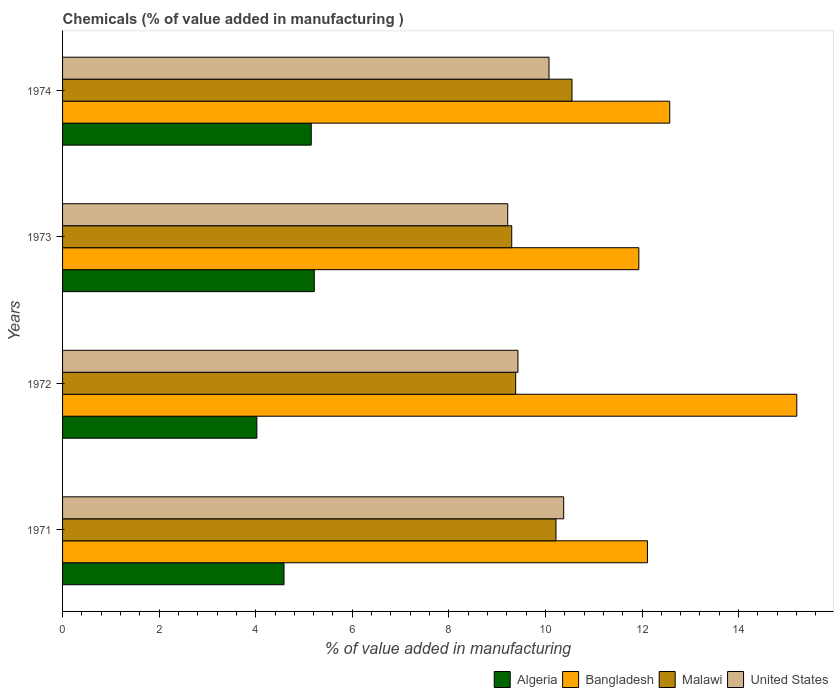Are the number of bars on each tick of the Y-axis equal?
Offer a very short reply. Yes. How many bars are there on the 1st tick from the top?
Keep it short and to the point. 4. What is the value added in manufacturing chemicals in Malawi in 1971?
Your answer should be compact. 10.22. Across all years, what is the maximum value added in manufacturing chemicals in Malawi?
Offer a terse response. 10.55. Across all years, what is the minimum value added in manufacturing chemicals in United States?
Your response must be concise. 9.22. In which year was the value added in manufacturing chemicals in United States maximum?
Ensure brevity in your answer.  1971. In which year was the value added in manufacturing chemicals in Malawi minimum?
Keep it short and to the point. 1973. What is the total value added in manufacturing chemicals in Malawi in the graph?
Provide a succinct answer. 39.45. What is the difference between the value added in manufacturing chemicals in United States in 1972 and that in 1974?
Keep it short and to the point. -0.64. What is the difference between the value added in manufacturing chemicals in Malawi in 1972 and the value added in manufacturing chemicals in United States in 1974?
Give a very brief answer. -0.69. What is the average value added in manufacturing chemicals in Bangladesh per year?
Keep it short and to the point. 12.96. In the year 1974, what is the difference between the value added in manufacturing chemicals in Bangladesh and value added in manufacturing chemicals in United States?
Your answer should be compact. 2.5. In how many years, is the value added in manufacturing chemicals in United States greater than 7.2 %?
Keep it short and to the point. 4. What is the ratio of the value added in manufacturing chemicals in Malawi in 1972 to that in 1974?
Offer a very short reply. 0.89. Is the value added in manufacturing chemicals in United States in 1971 less than that in 1973?
Keep it short and to the point. No. What is the difference between the highest and the second highest value added in manufacturing chemicals in Malawi?
Make the answer very short. 0.33. What is the difference between the highest and the lowest value added in manufacturing chemicals in United States?
Offer a terse response. 1.16. In how many years, is the value added in manufacturing chemicals in Bangladesh greater than the average value added in manufacturing chemicals in Bangladesh taken over all years?
Offer a very short reply. 1. Is it the case that in every year, the sum of the value added in manufacturing chemicals in Algeria and value added in manufacturing chemicals in Malawi is greater than the sum of value added in manufacturing chemicals in United States and value added in manufacturing chemicals in Bangladesh?
Provide a short and direct response. No. What does the 1st bar from the bottom in 1973 represents?
Ensure brevity in your answer.  Algeria. Is it the case that in every year, the sum of the value added in manufacturing chemicals in Malawi and value added in manufacturing chemicals in Bangladesh is greater than the value added in manufacturing chemicals in Algeria?
Ensure brevity in your answer.  Yes. How many bars are there?
Offer a very short reply. 16. How many years are there in the graph?
Give a very brief answer. 4. What is the difference between two consecutive major ticks on the X-axis?
Provide a short and direct response. 2. Does the graph contain any zero values?
Your answer should be compact. No. Does the graph contain grids?
Your response must be concise. No. Where does the legend appear in the graph?
Your answer should be very brief. Bottom right. How many legend labels are there?
Your response must be concise. 4. What is the title of the graph?
Make the answer very short. Chemicals (% of value added in manufacturing ). Does "South Sudan" appear as one of the legend labels in the graph?
Your response must be concise. No. What is the label or title of the X-axis?
Offer a very short reply. % of value added in manufacturing. What is the label or title of the Y-axis?
Provide a succinct answer. Years. What is the % of value added in manufacturing of Algeria in 1971?
Offer a terse response. 4.59. What is the % of value added in manufacturing of Bangladesh in 1971?
Offer a terse response. 12.11. What is the % of value added in manufacturing in Malawi in 1971?
Your answer should be very brief. 10.22. What is the % of value added in manufacturing of United States in 1971?
Keep it short and to the point. 10.38. What is the % of value added in manufacturing of Algeria in 1972?
Your answer should be compact. 4.02. What is the % of value added in manufacturing in Bangladesh in 1972?
Keep it short and to the point. 15.2. What is the % of value added in manufacturing in Malawi in 1972?
Give a very brief answer. 9.38. What is the % of value added in manufacturing in United States in 1972?
Make the answer very short. 9.43. What is the % of value added in manufacturing in Algeria in 1973?
Your answer should be very brief. 5.21. What is the % of value added in manufacturing of Bangladesh in 1973?
Offer a terse response. 11.93. What is the % of value added in manufacturing in Malawi in 1973?
Ensure brevity in your answer.  9.3. What is the % of value added in manufacturing of United States in 1973?
Offer a terse response. 9.22. What is the % of value added in manufacturing of Algeria in 1974?
Provide a short and direct response. 5.15. What is the % of value added in manufacturing of Bangladesh in 1974?
Offer a very short reply. 12.57. What is the % of value added in manufacturing in Malawi in 1974?
Ensure brevity in your answer.  10.55. What is the % of value added in manufacturing in United States in 1974?
Keep it short and to the point. 10.07. Across all years, what is the maximum % of value added in manufacturing of Algeria?
Keep it short and to the point. 5.21. Across all years, what is the maximum % of value added in manufacturing in Bangladesh?
Ensure brevity in your answer.  15.2. Across all years, what is the maximum % of value added in manufacturing of Malawi?
Your answer should be very brief. 10.55. Across all years, what is the maximum % of value added in manufacturing of United States?
Keep it short and to the point. 10.38. Across all years, what is the minimum % of value added in manufacturing in Algeria?
Your response must be concise. 4.02. Across all years, what is the minimum % of value added in manufacturing in Bangladesh?
Offer a terse response. 11.93. Across all years, what is the minimum % of value added in manufacturing of Malawi?
Offer a very short reply. 9.3. Across all years, what is the minimum % of value added in manufacturing in United States?
Provide a succinct answer. 9.22. What is the total % of value added in manufacturing in Algeria in the graph?
Your response must be concise. 18.97. What is the total % of value added in manufacturing in Bangladesh in the graph?
Offer a terse response. 51.83. What is the total % of value added in manufacturing in Malawi in the graph?
Make the answer very short. 39.45. What is the total % of value added in manufacturing in United States in the graph?
Offer a terse response. 39.1. What is the difference between the % of value added in manufacturing in Algeria in 1971 and that in 1972?
Keep it short and to the point. 0.56. What is the difference between the % of value added in manufacturing in Bangladesh in 1971 and that in 1972?
Provide a short and direct response. -3.09. What is the difference between the % of value added in manufacturing of Malawi in 1971 and that in 1972?
Give a very brief answer. 0.83. What is the difference between the % of value added in manufacturing of United States in 1971 and that in 1972?
Your response must be concise. 0.95. What is the difference between the % of value added in manufacturing of Algeria in 1971 and that in 1973?
Provide a succinct answer. -0.63. What is the difference between the % of value added in manufacturing of Bangladesh in 1971 and that in 1973?
Ensure brevity in your answer.  0.18. What is the difference between the % of value added in manufacturing of Malawi in 1971 and that in 1973?
Keep it short and to the point. 0.92. What is the difference between the % of value added in manufacturing in United States in 1971 and that in 1973?
Offer a terse response. 1.16. What is the difference between the % of value added in manufacturing of Algeria in 1971 and that in 1974?
Ensure brevity in your answer.  -0.56. What is the difference between the % of value added in manufacturing of Bangladesh in 1971 and that in 1974?
Provide a short and direct response. -0.46. What is the difference between the % of value added in manufacturing of Malawi in 1971 and that in 1974?
Your answer should be very brief. -0.33. What is the difference between the % of value added in manufacturing in United States in 1971 and that in 1974?
Give a very brief answer. 0.3. What is the difference between the % of value added in manufacturing in Algeria in 1972 and that in 1973?
Offer a very short reply. -1.19. What is the difference between the % of value added in manufacturing in Bangladesh in 1972 and that in 1973?
Offer a very short reply. 3.27. What is the difference between the % of value added in manufacturing of Malawi in 1972 and that in 1973?
Offer a terse response. 0.08. What is the difference between the % of value added in manufacturing of United States in 1972 and that in 1973?
Your answer should be compact. 0.21. What is the difference between the % of value added in manufacturing in Algeria in 1972 and that in 1974?
Make the answer very short. -1.13. What is the difference between the % of value added in manufacturing of Bangladesh in 1972 and that in 1974?
Provide a succinct answer. 2.63. What is the difference between the % of value added in manufacturing in Malawi in 1972 and that in 1974?
Give a very brief answer. -1.17. What is the difference between the % of value added in manufacturing in United States in 1972 and that in 1974?
Give a very brief answer. -0.64. What is the difference between the % of value added in manufacturing in Algeria in 1973 and that in 1974?
Your answer should be very brief. 0.06. What is the difference between the % of value added in manufacturing in Bangladesh in 1973 and that in 1974?
Provide a succinct answer. -0.64. What is the difference between the % of value added in manufacturing in Malawi in 1973 and that in 1974?
Offer a very short reply. -1.25. What is the difference between the % of value added in manufacturing of United States in 1973 and that in 1974?
Offer a terse response. -0.85. What is the difference between the % of value added in manufacturing of Algeria in 1971 and the % of value added in manufacturing of Bangladesh in 1972?
Offer a terse response. -10.62. What is the difference between the % of value added in manufacturing of Algeria in 1971 and the % of value added in manufacturing of Malawi in 1972?
Your answer should be very brief. -4.8. What is the difference between the % of value added in manufacturing of Algeria in 1971 and the % of value added in manufacturing of United States in 1972?
Provide a short and direct response. -4.84. What is the difference between the % of value added in manufacturing in Bangladesh in 1971 and the % of value added in manufacturing in Malawi in 1972?
Your response must be concise. 2.73. What is the difference between the % of value added in manufacturing of Bangladesh in 1971 and the % of value added in manufacturing of United States in 1972?
Your answer should be very brief. 2.68. What is the difference between the % of value added in manufacturing in Malawi in 1971 and the % of value added in manufacturing in United States in 1972?
Make the answer very short. 0.79. What is the difference between the % of value added in manufacturing in Algeria in 1971 and the % of value added in manufacturing in Bangladesh in 1973?
Ensure brevity in your answer.  -7.35. What is the difference between the % of value added in manufacturing in Algeria in 1971 and the % of value added in manufacturing in Malawi in 1973?
Your answer should be very brief. -4.72. What is the difference between the % of value added in manufacturing of Algeria in 1971 and the % of value added in manufacturing of United States in 1973?
Your response must be concise. -4.63. What is the difference between the % of value added in manufacturing of Bangladesh in 1971 and the % of value added in manufacturing of Malawi in 1973?
Offer a terse response. 2.81. What is the difference between the % of value added in manufacturing in Bangladesh in 1971 and the % of value added in manufacturing in United States in 1973?
Your answer should be compact. 2.89. What is the difference between the % of value added in manufacturing in Algeria in 1971 and the % of value added in manufacturing in Bangladesh in 1974?
Provide a short and direct response. -7.99. What is the difference between the % of value added in manufacturing in Algeria in 1971 and the % of value added in manufacturing in Malawi in 1974?
Offer a terse response. -5.96. What is the difference between the % of value added in manufacturing of Algeria in 1971 and the % of value added in manufacturing of United States in 1974?
Your response must be concise. -5.49. What is the difference between the % of value added in manufacturing of Bangladesh in 1971 and the % of value added in manufacturing of Malawi in 1974?
Your response must be concise. 1.56. What is the difference between the % of value added in manufacturing in Bangladesh in 1971 and the % of value added in manufacturing in United States in 1974?
Ensure brevity in your answer.  2.04. What is the difference between the % of value added in manufacturing in Malawi in 1971 and the % of value added in manufacturing in United States in 1974?
Provide a succinct answer. 0.14. What is the difference between the % of value added in manufacturing in Algeria in 1972 and the % of value added in manufacturing in Bangladesh in 1973?
Offer a very short reply. -7.91. What is the difference between the % of value added in manufacturing of Algeria in 1972 and the % of value added in manufacturing of Malawi in 1973?
Offer a terse response. -5.28. What is the difference between the % of value added in manufacturing in Algeria in 1972 and the % of value added in manufacturing in United States in 1973?
Your answer should be very brief. -5.2. What is the difference between the % of value added in manufacturing of Bangladesh in 1972 and the % of value added in manufacturing of Malawi in 1973?
Provide a succinct answer. 5.9. What is the difference between the % of value added in manufacturing in Bangladesh in 1972 and the % of value added in manufacturing in United States in 1973?
Provide a succinct answer. 5.99. What is the difference between the % of value added in manufacturing of Malawi in 1972 and the % of value added in manufacturing of United States in 1973?
Ensure brevity in your answer.  0.17. What is the difference between the % of value added in manufacturing of Algeria in 1972 and the % of value added in manufacturing of Bangladesh in 1974?
Your response must be concise. -8.55. What is the difference between the % of value added in manufacturing of Algeria in 1972 and the % of value added in manufacturing of Malawi in 1974?
Give a very brief answer. -6.53. What is the difference between the % of value added in manufacturing in Algeria in 1972 and the % of value added in manufacturing in United States in 1974?
Keep it short and to the point. -6.05. What is the difference between the % of value added in manufacturing in Bangladesh in 1972 and the % of value added in manufacturing in Malawi in 1974?
Offer a very short reply. 4.66. What is the difference between the % of value added in manufacturing in Bangladesh in 1972 and the % of value added in manufacturing in United States in 1974?
Offer a very short reply. 5.13. What is the difference between the % of value added in manufacturing in Malawi in 1972 and the % of value added in manufacturing in United States in 1974?
Offer a terse response. -0.69. What is the difference between the % of value added in manufacturing of Algeria in 1973 and the % of value added in manufacturing of Bangladesh in 1974?
Your answer should be compact. -7.36. What is the difference between the % of value added in manufacturing in Algeria in 1973 and the % of value added in manufacturing in Malawi in 1974?
Give a very brief answer. -5.34. What is the difference between the % of value added in manufacturing in Algeria in 1973 and the % of value added in manufacturing in United States in 1974?
Your answer should be compact. -4.86. What is the difference between the % of value added in manufacturing of Bangladesh in 1973 and the % of value added in manufacturing of Malawi in 1974?
Provide a short and direct response. 1.38. What is the difference between the % of value added in manufacturing of Bangladesh in 1973 and the % of value added in manufacturing of United States in 1974?
Give a very brief answer. 1.86. What is the difference between the % of value added in manufacturing of Malawi in 1973 and the % of value added in manufacturing of United States in 1974?
Provide a succinct answer. -0.77. What is the average % of value added in manufacturing in Algeria per year?
Provide a short and direct response. 4.74. What is the average % of value added in manufacturing of Bangladesh per year?
Your answer should be compact. 12.96. What is the average % of value added in manufacturing in Malawi per year?
Give a very brief answer. 9.86. What is the average % of value added in manufacturing in United States per year?
Your answer should be compact. 9.78. In the year 1971, what is the difference between the % of value added in manufacturing in Algeria and % of value added in manufacturing in Bangladesh?
Make the answer very short. -7.53. In the year 1971, what is the difference between the % of value added in manufacturing of Algeria and % of value added in manufacturing of Malawi?
Your answer should be very brief. -5.63. In the year 1971, what is the difference between the % of value added in manufacturing in Algeria and % of value added in manufacturing in United States?
Provide a short and direct response. -5.79. In the year 1971, what is the difference between the % of value added in manufacturing in Bangladesh and % of value added in manufacturing in Malawi?
Your answer should be very brief. 1.89. In the year 1971, what is the difference between the % of value added in manufacturing of Bangladesh and % of value added in manufacturing of United States?
Your answer should be very brief. 1.73. In the year 1971, what is the difference between the % of value added in manufacturing of Malawi and % of value added in manufacturing of United States?
Offer a terse response. -0.16. In the year 1972, what is the difference between the % of value added in manufacturing of Algeria and % of value added in manufacturing of Bangladesh?
Keep it short and to the point. -11.18. In the year 1972, what is the difference between the % of value added in manufacturing in Algeria and % of value added in manufacturing in Malawi?
Your response must be concise. -5.36. In the year 1972, what is the difference between the % of value added in manufacturing in Algeria and % of value added in manufacturing in United States?
Offer a very short reply. -5.41. In the year 1972, what is the difference between the % of value added in manufacturing of Bangladesh and % of value added in manufacturing of Malawi?
Ensure brevity in your answer.  5.82. In the year 1972, what is the difference between the % of value added in manufacturing in Bangladesh and % of value added in manufacturing in United States?
Keep it short and to the point. 5.77. In the year 1972, what is the difference between the % of value added in manufacturing of Malawi and % of value added in manufacturing of United States?
Give a very brief answer. -0.05. In the year 1973, what is the difference between the % of value added in manufacturing of Algeria and % of value added in manufacturing of Bangladesh?
Give a very brief answer. -6.72. In the year 1973, what is the difference between the % of value added in manufacturing in Algeria and % of value added in manufacturing in Malawi?
Keep it short and to the point. -4.09. In the year 1973, what is the difference between the % of value added in manufacturing of Algeria and % of value added in manufacturing of United States?
Your answer should be very brief. -4.01. In the year 1973, what is the difference between the % of value added in manufacturing of Bangladesh and % of value added in manufacturing of Malawi?
Offer a very short reply. 2.63. In the year 1973, what is the difference between the % of value added in manufacturing in Bangladesh and % of value added in manufacturing in United States?
Your answer should be very brief. 2.72. In the year 1973, what is the difference between the % of value added in manufacturing of Malawi and % of value added in manufacturing of United States?
Give a very brief answer. 0.08. In the year 1974, what is the difference between the % of value added in manufacturing of Algeria and % of value added in manufacturing of Bangladesh?
Your answer should be compact. -7.42. In the year 1974, what is the difference between the % of value added in manufacturing of Algeria and % of value added in manufacturing of Malawi?
Your response must be concise. -5.4. In the year 1974, what is the difference between the % of value added in manufacturing in Algeria and % of value added in manufacturing in United States?
Provide a succinct answer. -4.92. In the year 1974, what is the difference between the % of value added in manufacturing in Bangladesh and % of value added in manufacturing in Malawi?
Keep it short and to the point. 2.02. In the year 1974, what is the difference between the % of value added in manufacturing in Bangladesh and % of value added in manufacturing in United States?
Offer a terse response. 2.5. In the year 1974, what is the difference between the % of value added in manufacturing of Malawi and % of value added in manufacturing of United States?
Make the answer very short. 0.48. What is the ratio of the % of value added in manufacturing of Algeria in 1971 to that in 1972?
Offer a terse response. 1.14. What is the ratio of the % of value added in manufacturing in Bangladesh in 1971 to that in 1972?
Give a very brief answer. 0.8. What is the ratio of the % of value added in manufacturing in Malawi in 1971 to that in 1972?
Offer a terse response. 1.09. What is the ratio of the % of value added in manufacturing of United States in 1971 to that in 1972?
Provide a short and direct response. 1.1. What is the ratio of the % of value added in manufacturing of Algeria in 1971 to that in 1973?
Offer a very short reply. 0.88. What is the ratio of the % of value added in manufacturing in Bangladesh in 1971 to that in 1973?
Offer a very short reply. 1.01. What is the ratio of the % of value added in manufacturing in Malawi in 1971 to that in 1973?
Make the answer very short. 1.1. What is the ratio of the % of value added in manufacturing of United States in 1971 to that in 1973?
Keep it short and to the point. 1.13. What is the ratio of the % of value added in manufacturing in Algeria in 1971 to that in 1974?
Your answer should be compact. 0.89. What is the ratio of the % of value added in manufacturing in Bangladesh in 1971 to that in 1974?
Provide a short and direct response. 0.96. What is the ratio of the % of value added in manufacturing of Malawi in 1971 to that in 1974?
Ensure brevity in your answer.  0.97. What is the ratio of the % of value added in manufacturing in United States in 1971 to that in 1974?
Your response must be concise. 1.03. What is the ratio of the % of value added in manufacturing of Algeria in 1972 to that in 1973?
Your answer should be very brief. 0.77. What is the ratio of the % of value added in manufacturing in Bangladesh in 1972 to that in 1973?
Make the answer very short. 1.27. What is the ratio of the % of value added in manufacturing in Malawi in 1972 to that in 1973?
Keep it short and to the point. 1.01. What is the ratio of the % of value added in manufacturing in Algeria in 1972 to that in 1974?
Your answer should be very brief. 0.78. What is the ratio of the % of value added in manufacturing in Bangladesh in 1972 to that in 1974?
Keep it short and to the point. 1.21. What is the ratio of the % of value added in manufacturing in Malawi in 1972 to that in 1974?
Keep it short and to the point. 0.89. What is the ratio of the % of value added in manufacturing of United States in 1972 to that in 1974?
Offer a very short reply. 0.94. What is the ratio of the % of value added in manufacturing in Algeria in 1973 to that in 1974?
Offer a very short reply. 1.01. What is the ratio of the % of value added in manufacturing in Bangladesh in 1973 to that in 1974?
Your answer should be compact. 0.95. What is the ratio of the % of value added in manufacturing in Malawi in 1973 to that in 1974?
Ensure brevity in your answer.  0.88. What is the ratio of the % of value added in manufacturing of United States in 1973 to that in 1974?
Make the answer very short. 0.92. What is the difference between the highest and the second highest % of value added in manufacturing in Algeria?
Your answer should be very brief. 0.06. What is the difference between the highest and the second highest % of value added in manufacturing in Bangladesh?
Offer a very short reply. 2.63. What is the difference between the highest and the second highest % of value added in manufacturing in Malawi?
Your response must be concise. 0.33. What is the difference between the highest and the second highest % of value added in manufacturing in United States?
Keep it short and to the point. 0.3. What is the difference between the highest and the lowest % of value added in manufacturing in Algeria?
Ensure brevity in your answer.  1.19. What is the difference between the highest and the lowest % of value added in manufacturing of Bangladesh?
Make the answer very short. 3.27. What is the difference between the highest and the lowest % of value added in manufacturing of Malawi?
Ensure brevity in your answer.  1.25. What is the difference between the highest and the lowest % of value added in manufacturing in United States?
Provide a short and direct response. 1.16. 